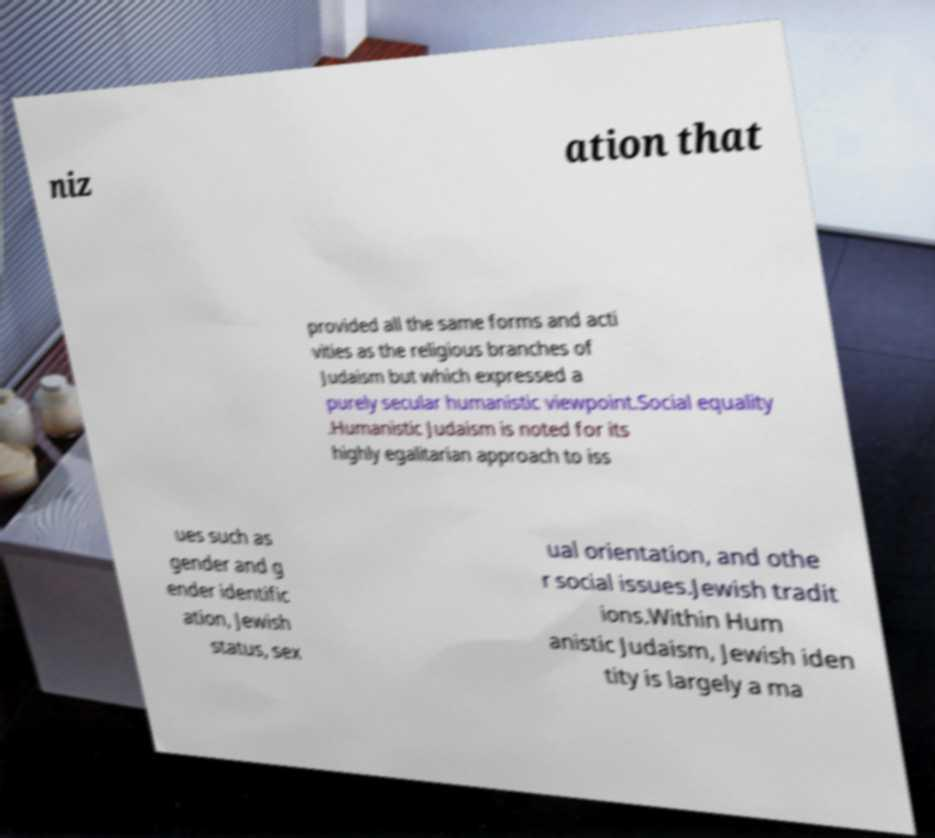Can you read and provide the text displayed in the image?This photo seems to have some interesting text. Can you extract and type it out for me? niz ation that provided all the same forms and acti vities as the religious branches of Judaism but which expressed a purely secular humanistic viewpoint.Social equality .Humanistic Judaism is noted for its highly egalitarian approach to iss ues such as gender and g ender identific ation, Jewish status, sex ual orientation, and othe r social issues.Jewish tradit ions.Within Hum anistic Judaism, Jewish iden tity is largely a ma 